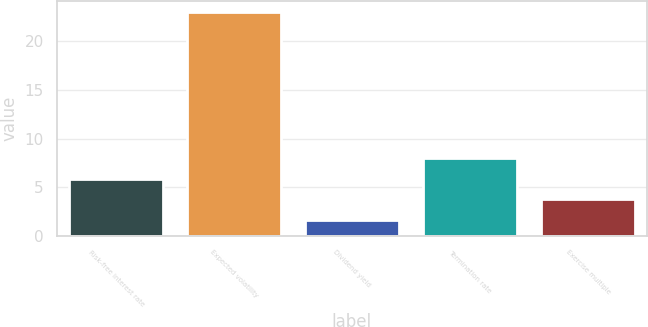Convert chart. <chart><loc_0><loc_0><loc_500><loc_500><bar_chart><fcel>Risk-free interest rate<fcel>Expected volatility<fcel>Dividend yield<fcel>Termination rate<fcel>Exercise multiple<nl><fcel>5.89<fcel>23<fcel>1.61<fcel>8.03<fcel>3.75<nl></chart> 